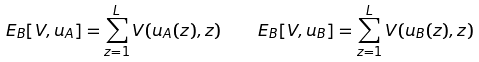<formula> <loc_0><loc_0><loc_500><loc_500>E _ { B } [ V , u _ { A } ] = \sum _ { z = 1 } ^ { L } V ( u _ { A } ( z ) , z ) \quad E _ { B } [ V , u _ { B } ] = \sum _ { z = 1 } ^ { L } V ( u _ { B } ( z ) , z )</formula> 